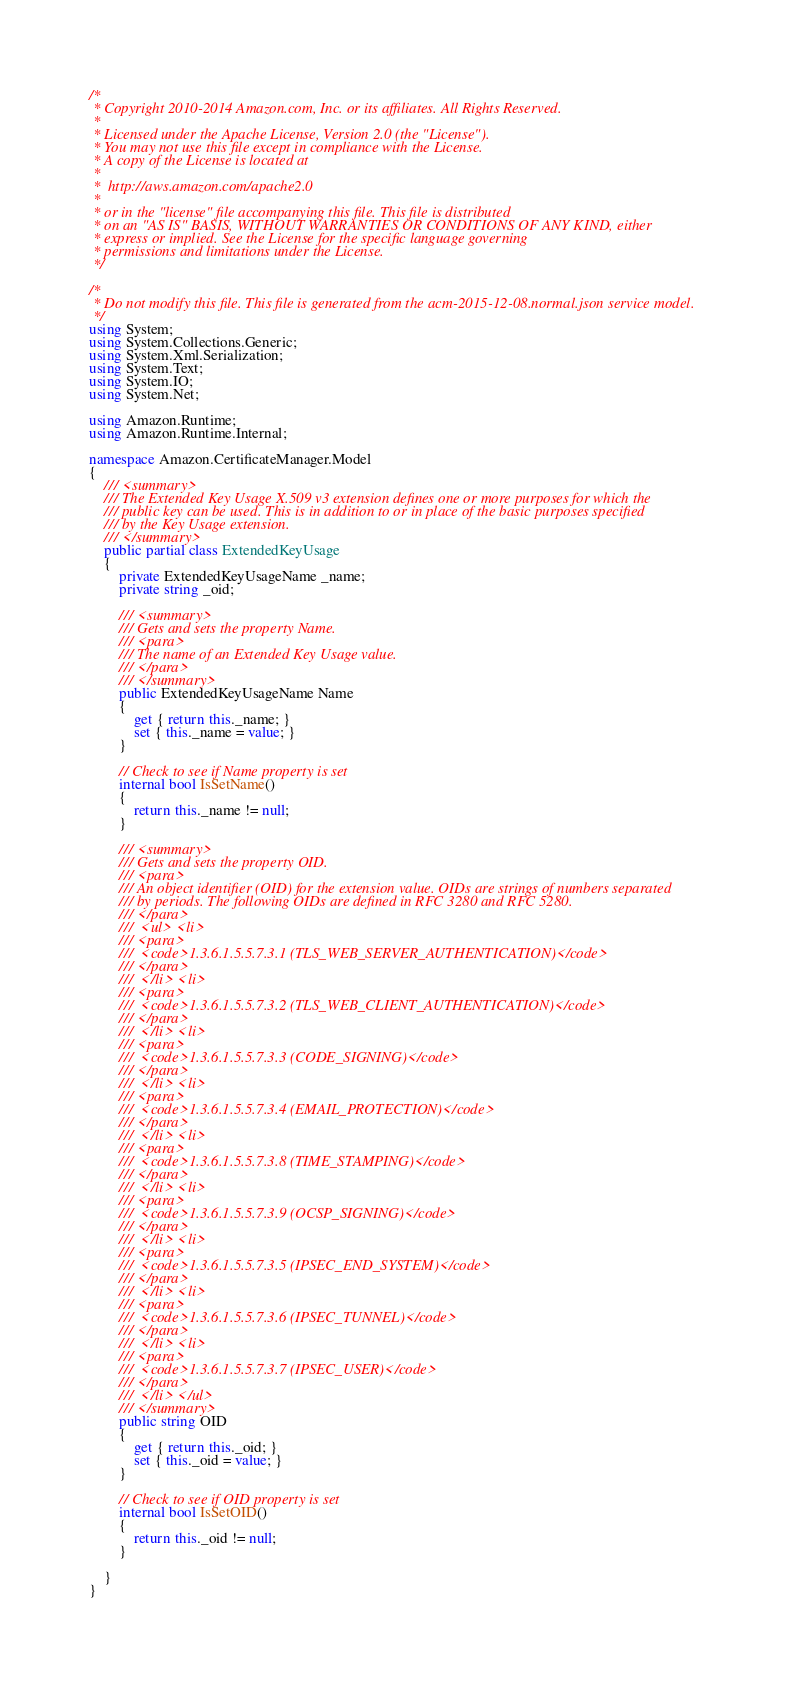Convert code to text. <code><loc_0><loc_0><loc_500><loc_500><_C#_>/*
 * Copyright 2010-2014 Amazon.com, Inc. or its affiliates. All Rights Reserved.
 * 
 * Licensed under the Apache License, Version 2.0 (the "License").
 * You may not use this file except in compliance with the License.
 * A copy of the License is located at
 * 
 *  http://aws.amazon.com/apache2.0
 * 
 * or in the "license" file accompanying this file. This file is distributed
 * on an "AS IS" BASIS, WITHOUT WARRANTIES OR CONDITIONS OF ANY KIND, either
 * express or implied. See the License for the specific language governing
 * permissions and limitations under the License.
 */

/*
 * Do not modify this file. This file is generated from the acm-2015-12-08.normal.json service model.
 */
using System;
using System.Collections.Generic;
using System.Xml.Serialization;
using System.Text;
using System.IO;
using System.Net;

using Amazon.Runtime;
using Amazon.Runtime.Internal;

namespace Amazon.CertificateManager.Model
{
    /// <summary>
    /// The Extended Key Usage X.509 v3 extension defines one or more purposes for which the
    /// public key can be used. This is in addition to or in place of the basic purposes specified
    /// by the Key Usage extension.
    /// </summary>
    public partial class ExtendedKeyUsage
    {
        private ExtendedKeyUsageName _name;
        private string _oid;

        /// <summary>
        /// Gets and sets the property Name. 
        /// <para>
        /// The name of an Extended Key Usage value.
        /// </para>
        /// </summary>
        public ExtendedKeyUsageName Name
        {
            get { return this._name; }
            set { this._name = value; }
        }

        // Check to see if Name property is set
        internal bool IsSetName()
        {
            return this._name != null;
        }

        /// <summary>
        /// Gets and sets the property OID. 
        /// <para>
        /// An object identifier (OID) for the extension value. OIDs are strings of numbers separated
        /// by periods. The following OIDs are defined in RFC 3280 and RFC 5280. 
        /// </para>
        ///  <ul> <li> 
        /// <para>
        ///  <code>1.3.6.1.5.5.7.3.1 (TLS_WEB_SERVER_AUTHENTICATION)</code> 
        /// </para>
        ///  </li> <li> 
        /// <para>
        ///  <code>1.3.6.1.5.5.7.3.2 (TLS_WEB_CLIENT_AUTHENTICATION)</code> 
        /// </para>
        ///  </li> <li> 
        /// <para>
        ///  <code>1.3.6.1.5.5.7.3.3 (CODE_SIGNING)</code> 
        /// </para>
        ///  </li> <li> 
        /// <para>
        ///  <code>1.3.6.1.5.5.7.3.4 (EMAIL_PROTECTION)</code> 
        /// </para>
        ///  </li> <li> 
        /// <para>
        ///  <code>1.3.6.1.5.5.7.3.8 (TIME_STAMPING)</code> 
        /// </para>
        ///  </li> <li> 
        /// <para>
        ///  <code>1.3.6.1.5.5.7.3.9 (OCSP_SIGNING)</code> 
        /// </para>
        ///  </li> <li> 
        /// <para>
        ///  <code>1.3.6.1.5.5.7.3.5 (IPSEC_END_SYSTEM)</code> 
        /// </para>
        ///  </li> <li> 
        /// <para>
        ///  <code>1.3.6.1.5.5.7.3.6 (IPSEC_TUNNEL)</code> 
        /// </para>
        ///  </li> <li> 
        /// <para>
        ///  <code>1.3.6.1.5.5.7.3.7 (IPSEC_USER)</code> 
        /// </para>
        ///  </li> </ul>
        /// </summary>
        public string OID
        {
            get { return this._oid; }
            set { this._oid = value; }
        }

        // Check to see if OID property is set
        internal bool IsSetOID()
        {
            return this._oid != null;
        }

    }
}</code> 